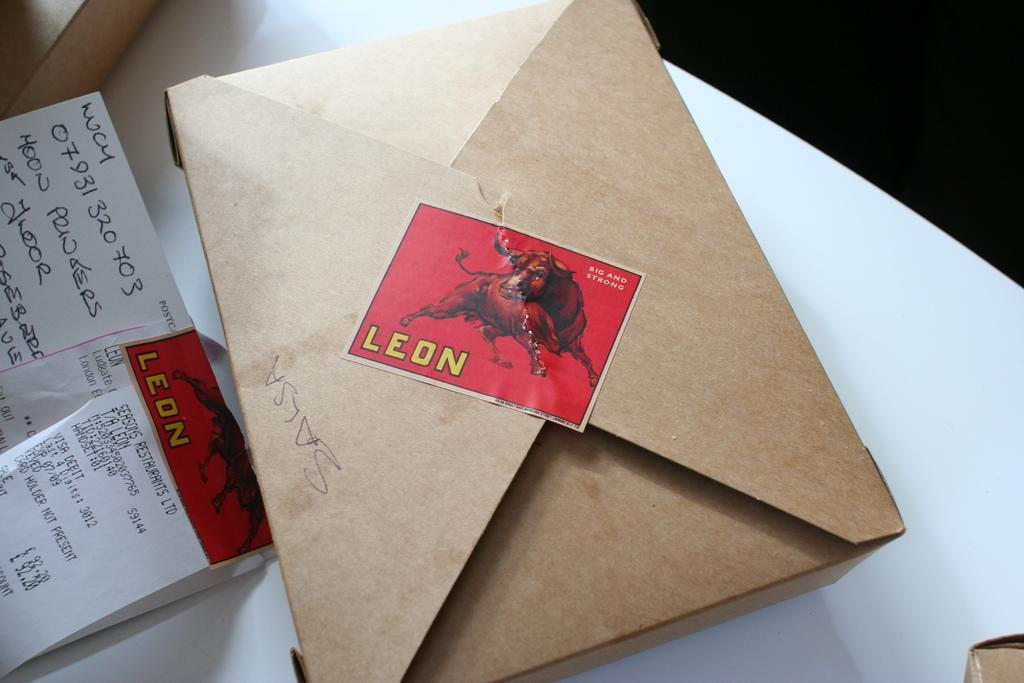<image>
Give a short and clear explanation of the subsequent image. An envelope with a red stamp reading Leon. 